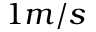<formula> <loc_0><loc_0><loc_500><loc_500>1 m / s</formula> 